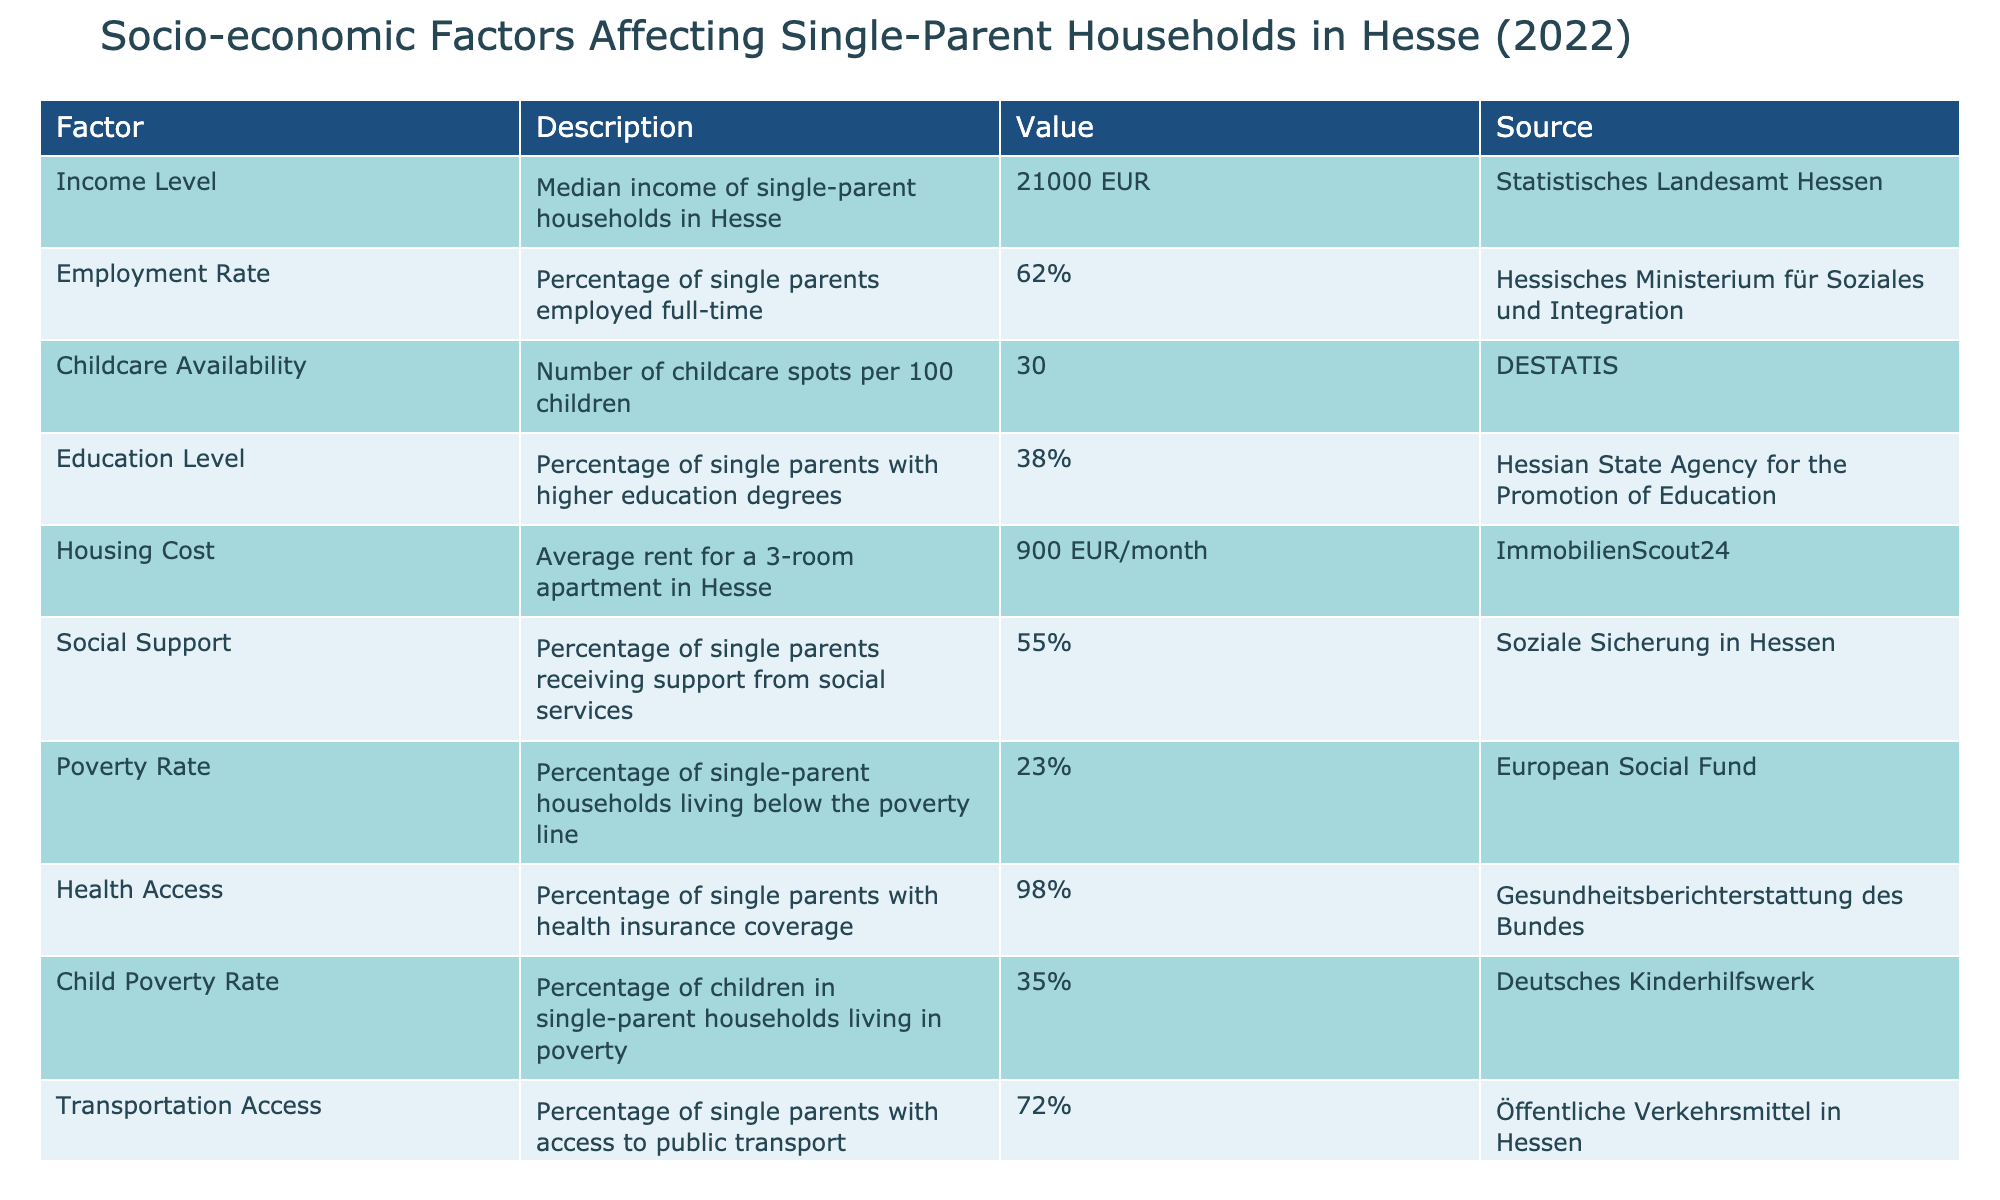What is the median income of single-parent households in Hesse? The table directly provides the median income of single-parent households under the "Income Level" factor, which is listed as 21000 EUR.
Answer: 21000 EUR What percentage of single parents are employed full-time in Hesse? The percentage of employed single parents is given in the table under the "Employment Rate" factor, specified as 62%.
Answer: 62% How many childcare spots are available per 100 children in Hesse? The table shows the number of childcare spots per 100 children under the "Childcare Availability" factor, which is reported as 30 spots.
Answer: 30 What is the average rent for a 3-room apartment in Hesse? The "Housing Cost" entry in the table states that the average rent for a 3-room apartment is 900 EUR per month.
Answer: 900 EUR/month What is the percentage of single-parent households living below the poverty line? According to the "Poverty Rate" factor, 23% of single-parent households in Hesse are reported to be living below the poverty line.
Answer: 23% Is the healthcare coverage for single parents in Hesse greater than 95%? The table indicates that 98% of single parents have health insurance coverage, which confirms that it is indeed greater than 95%.
Answer: Yes What is the difference in percentage between single parents with higher education and those receiving social support? From the table, 38% of single parents have higher education while 55% receive social support. The difference is calculated as 55% - 38% = 17%.
Answer: 17% Do more than 30% of children in single-parent households live in poverty? The "Child Poverty Rate" factor shows that 35% of children in single-parent households live in poverty, which is more than 30%.
Answer: Yes What percentage of single parents have access to public transport compared to those receiving social support? From the table, access to public transport is at 72% and social support at 55%. Since 72% is greater than 55%, the accessed percentage is higher.
Answer: 72% is higher than 55% What is the total percentage of single parents with either higher education or access to childcare? The table shows 38% of single parents with higher education and 30 spots for childcare availability. To find a total percentage considering the overlap is not specified, we can interpret it as 38% for higher education but not summed (as households may share both). Therefore, there is no total given explicitly, but education alone is 38% in this context.
Answer: 38% 